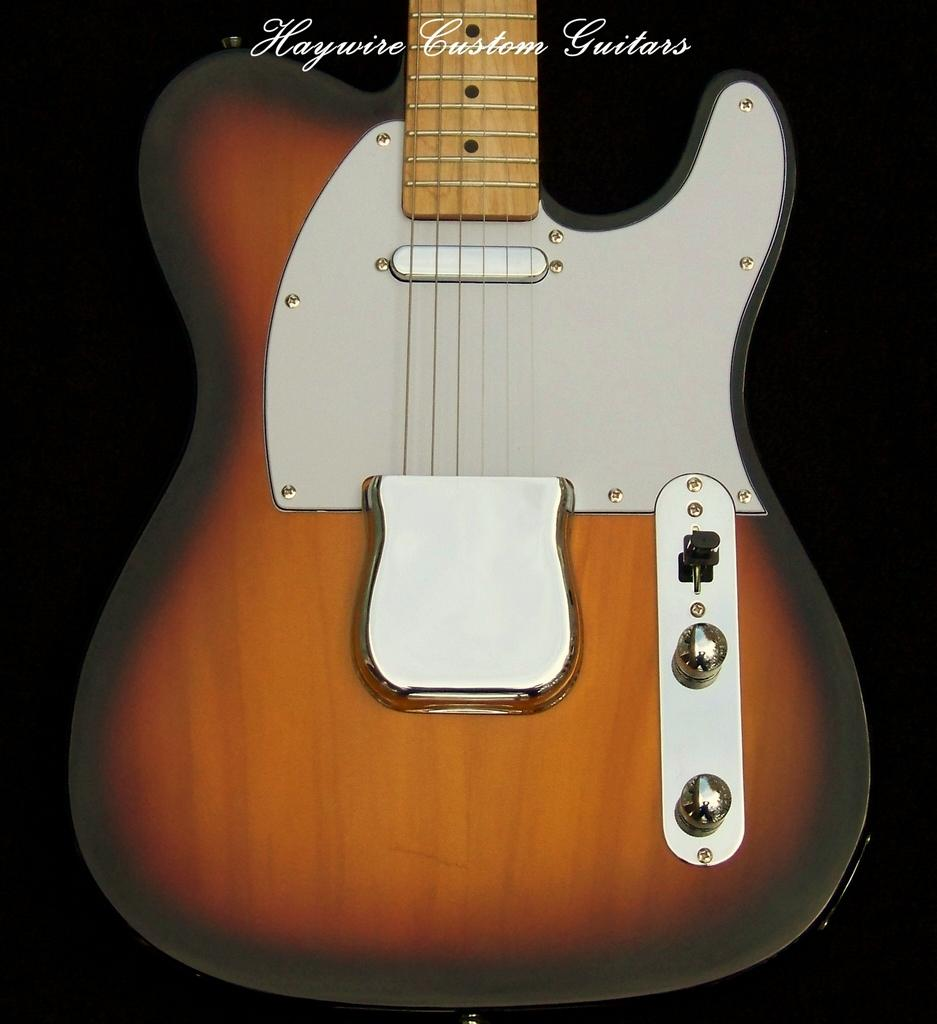What type of musical instrument is present in the image? There is a red color guitar in the image. What is the color of the guitar? The guitar is red in color. Is there a fire burning near the guitar in the image? No, there is no fire present in the image. What type of harmony is being played on the guitar in the image? The image does not show the guitar being played, so it is not possible to determine the type of harmony being played. 